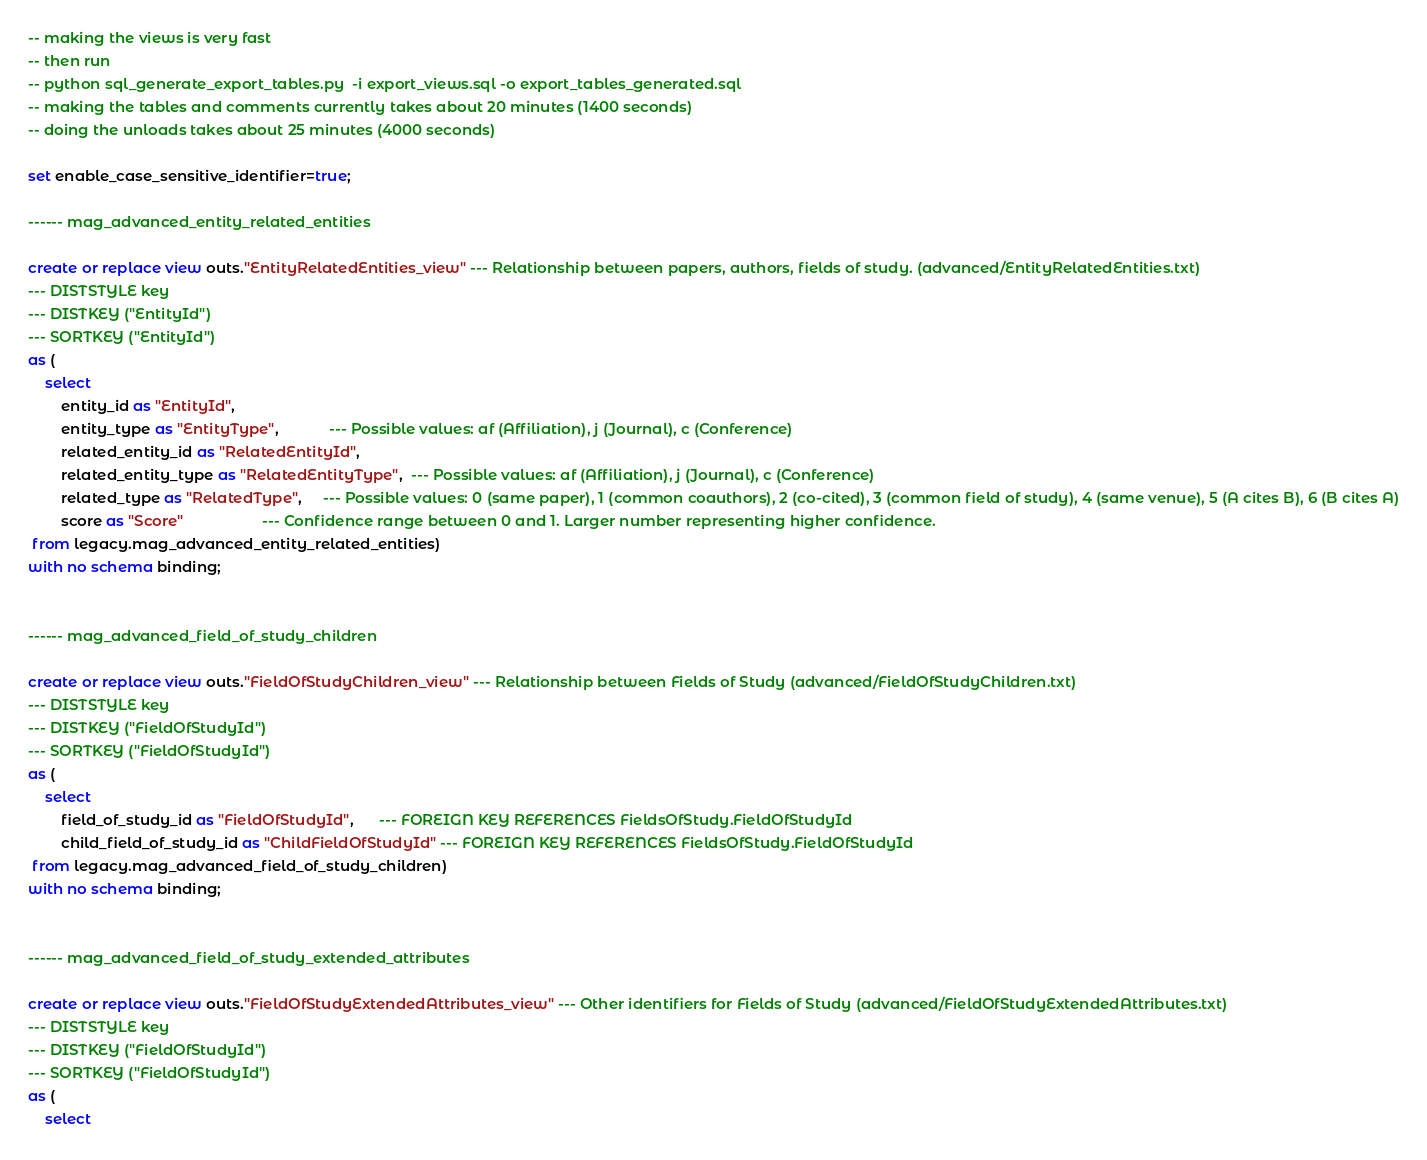Convert code to text. <code><loc_0><loc_0><loc_500><loc_500><_SQL_>-- making the views is very fast
-- then run
-- python sql_generate_export_tables.py  -i export_views.sql -o export_tables_generated.sql
-- making the tables and comments currently takes about 20 minutes (1400 seconds)
-- doing the unloads takes about 25 minutes (4000 seconds)

set enable_case_sensitive_identifier=true;

------ mag_advanced_entity_related_entities

create or replace view outs."EntityRelatedEntities_view" --- Relationship between papers, authors, fields of study. (advanced/EntityRelatedEntities.txt)
--- DISTSTYLE key
--- DISTKEY ("EntityId")
--- SORTKEY ("EntityId")
as (
    select
        entity_id as "EntityId",
        entity_type as "EntityType",            --- Possible values: af (Affiliation), j (Journal), c (Conference)
        related_entity_id as "RelatedEntityId",
        related_entity_type as "RelatedEntityType",  --- Possible values: af (Affiliation), j (Journal), c (Conference)
        related_type as "RelatedType",     --- Possible values: 0 (same paper), 1 (common coauthors), 2 (co-cited), 3 (common field of study), 4 (same venue), 5 (A cites B), 6 (B cites A)
        score as "Score"                   --- Confidence range between 0 and 1. Larger number representing higher confidence.
 from legacy.mag_advanced_entity_related_entities)
with no schema binding;


------ mag_advanced_field_of_study_children

create or replace view outs."FieldOfStudyChildren_view" --- Relationship between Fields of Study (advanced/FieldOfStudyChildren.txt)
--- DISTSTYLE key
--- DISTKEY ("FieldOfStudyId")
--- SORTKEY ("FieldOfStudyId")
as (
    select
        field_of_study_id as "FieldOfStudyId",      --- FOREIGN KEY REFERENCES FieldsOfStudy.FieldOfStudyId
        child_field_of_study_id as "ChildFieldOfStudyId" --- FOREIGN KEY REFERENCES FieldsOfStudy.FieldOfStudyId
 from legacy.mag_advanced_field_of_study_children)
with no schema binding;


------ mag_advanced_field_of_study_extended_attributes

create or replace view outs."FieldOfStudyExtendedAttributes_view" --- Other identifiers for Fields of Study (advanced/FieldOfStudyExtendedAttributes.txt)
--- DISTSTYLE key
--- DISTKEY ("FieldOfStudyId")
--- SORTKEY ("FieldOfStudyId")
as (
    select</code> 